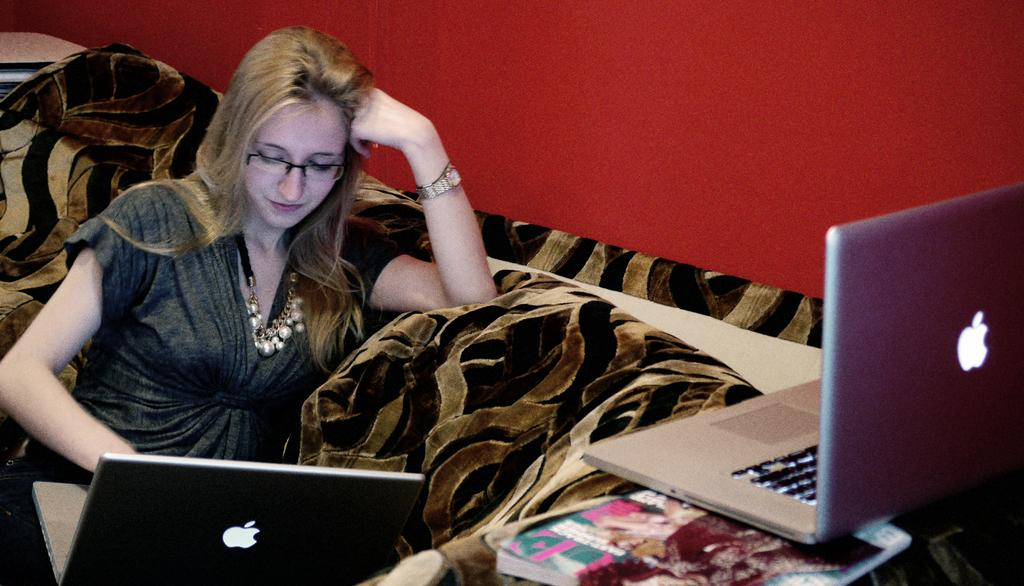Who is present in the image? There is a woman in the image. What accessories is the woman wearing? The woman is wearing spectacles and a watch. What is the woman doing in the image? The woman is sitting on a sofa. What electronic device can be seen in the image? There is a laptop in the image. What non-electronic item can be seen in the image? There is a book in the image. What color is the wall in the background of the image? There is a red wall in the background of the image. How many clovers are on the woman's shirt in the image? There are no clovers visible on the woman's shirt in the image. What shape is the basket that the woman is holding in the image? There is no basket present in the image. 